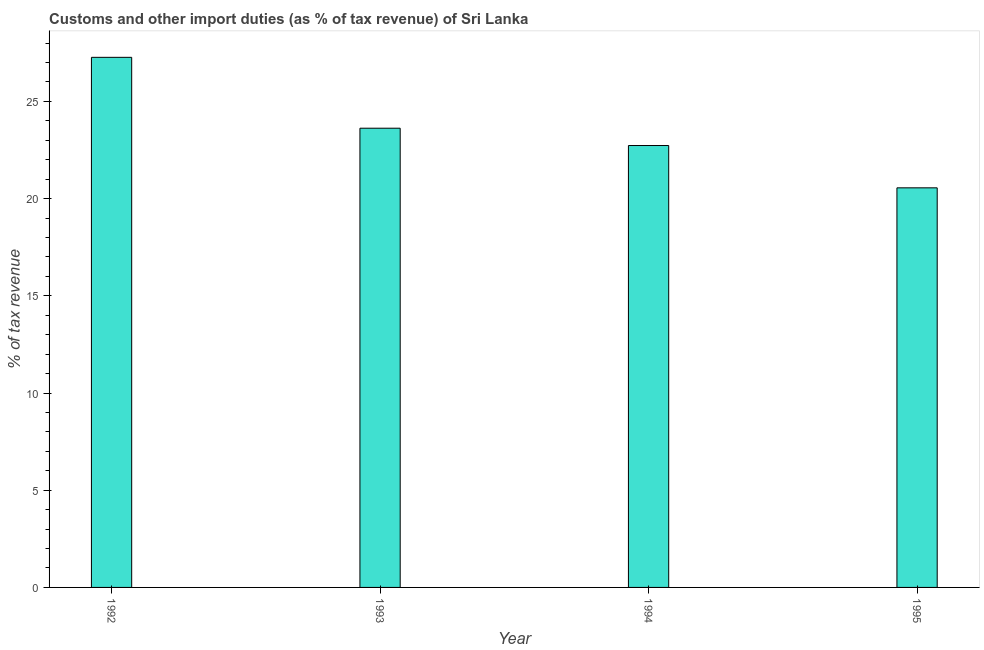Does the graph contain grids?
Keep it short and to the point. No. What is the title of the graph?
Keep it short and to the point. Customs and other import duties (as % of tax revenue) of Sri Lanka. What is the label or title of the Y-axis?
Provide a short and direct response. % of tax revenue. What is the customs and other import duties in 1992?
Offer a very short reply. 27.27. Across all years, what is the maximum customs and other import duties?
Your answer should be compact. 27.27. Across all years, what is the minimum customs and other import duties?
Provide a short and direct response. 20.55. In which year was the customs and other import duties minimum?
Provide a short and direct response. 1995. What is the sum of the customs and other import duties?
Keep it short and to the point. 94.17. What is the difference between the customs and other import duties in 1992 and 1994?
Offer a very short reply. 4.54. What is the average customs and other import duties per year?
Offer a terse response. 23.54. What is the median customs and other import duties?
Provide a short and direct response. 23.18. In how many years, is the customs and other import duties greater than 20 %?
Your answer should be compact. 4. Do a majority of the years between 1995 and 1994 (inclusive) have customs and other import duties greater than 2 %?
Your response must be concise. No. What is the ratio of the customs and other import duties in 1992 to that in 1993?
Your response must be concise. 1.15. Is the difference between the customs and other import duties in 1994 and 1995 greater than the difference between any two years?
Your answer should be compact. No. What is the difference between the highest and the second highest customs and other import duties?
Keep it short and to the point. 3.65. Is the sum of the customs and other import duties in 1993 and 1994 greater than the maximum customs and other import duties across all years?
Provide a short and direct response. Yes. What is the difference between the highest and the lowest customs and other import duties?
Ensure brevity in your answer.  6.71. In how many years, is the customs and other import duties greater than the average customs and other import duties taken over all years?
Make the answer very short. 2. How many bars are there?
Offer a terse response. 4. How many years are there in the graph?
Provide a succinct answer. 4. What is the difference between two consecutive major ticks on the Y-axis?
Keep it short and to the point. 5. What is the % of tax revenue of 1992?
Keep it short and to the point. 27.27. What is the % of tax revenue of 1993?
Offer a very short reply. 23.62. What is the % of tax revenue of 1994?
Ensure brevity in your answer.  22.73. What is the % of tax revenue in 1995?
Provide a short and direct response. 20.55. What is the difference between the % of tax revenue in 1992 and 1993?
Your response must be concise. 3.65. What is the difference between the % of tax revenue in 1992 and 1994?
Your answer should be compact. 4.54. What is the difference between the % of tax revenue in 1992 and 1995?
Your response must be concise. 6.71. What is the difference between the % of tax revenue in 1993 and 1994?
Your response must be concise. 0.89. What is the difference between the % of tax revenue in 1993 and 1995?
Offer a very short reply. 3.07. What is the difference between the % of tax revenue in 1994 and 1995?
Your answer should be very brief. 2.18. What is the ratio of the % of tax revenue in 1992 to that in 1993?
Offer a terse response. 1.15. What is the ratio of the % of tax revenue in 1992 to that in 1995?
Give a very brief answer. 1.33. What is the ratio of the % of tax revenue in 1993 to that in 1994?
Keep it short and to the point. 1.04. What is the ratio of the % of tax revenue in 1993 to that in 1995?
Your answer should be compact. 1.15. What is the ratio of the % of tax revenue in 1994 to that in 1995?
Provide a succinct answer. 1.11. 